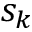Convert formula to latex. <formula><loc_0><loc_0><loc_500><loc_500>s _ { k }</formula> 